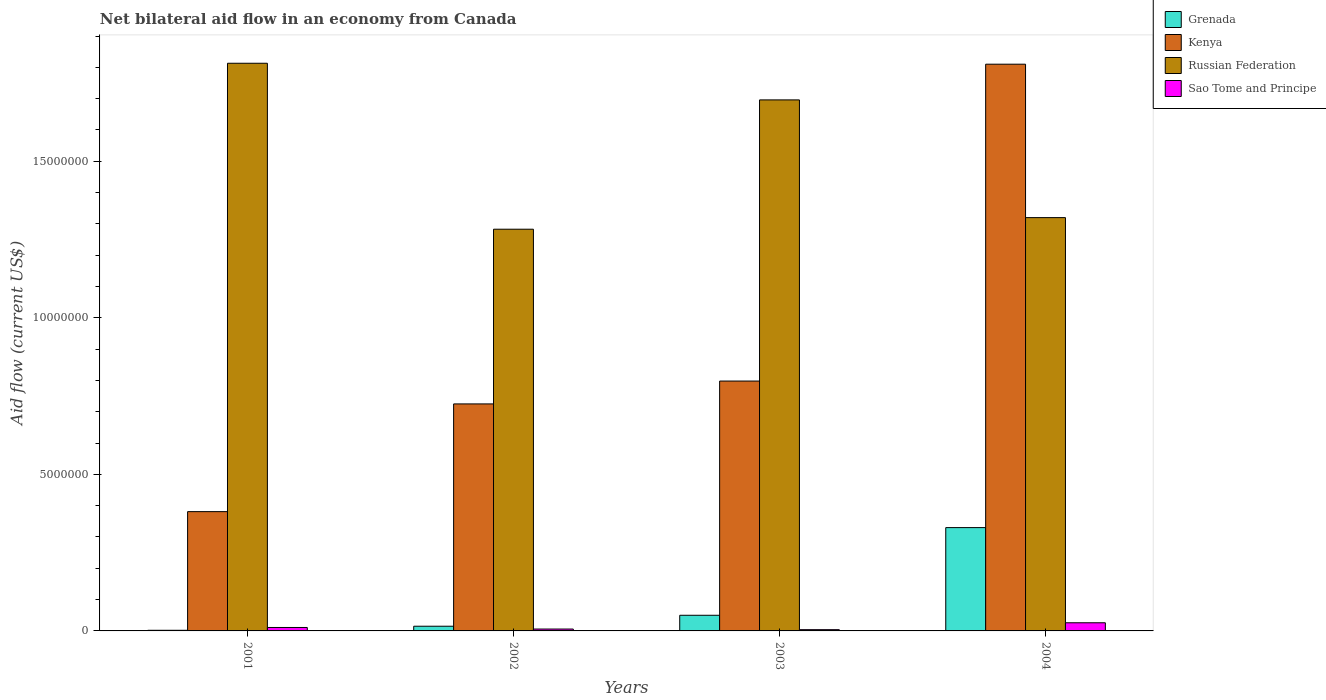Are the number of bars per tick equal to the number of legend labels?
Your answer should be compact. Yes. Are the number of bars on each tick of the X-axis equal?
Your response must be concise. Yes. In how many cases, is the number of bars for a given year not equal to the number of legend labels?
Your response must be concise. 0. What is the net bilateral aid flow in Grenada in 2001?
Your response must be concise. 2.00e+04. Across all years, what is the maximum net bilateral aid flow in Kenya?
Provide a short and direct response. 1.81e+07. Across all years, what is the minimum net bilateral aid flow in Kenya?
Keep it short and to the point. 3.81e+06. In which year was the net bilateral aid flow in Grenada maximum?
Give a very brief answer. 2004. What is the total net bilateral aid flow in Russian Federation in the graph?
Your response must be concise. 6.11e+07. What is the difference between the net bilateral aid flow in Grenada in 2002 and that in 2004?
Provide a short and direct response. -3.15e+06. What is the difference between the net bilateral aid flow in Grenada in 2003 and the net bilateral aid flow in Kenya in 2002?
Keep it short and to the point. -6.75e+06. What is the average net bilateral aid flow in Sao Tome and Principe per year?
Provide a succinct answer. 1.18e+05. In the year 2001, what is the difference between the net bilateral aid flow in Russian Federation and net bilateral aid flow in Grenada?
Provide a succinct answer. 1.81e+07. In how many years, is the net bilateral aid flow in Russian Federation greater than 2000000 US$?
Ensure brevity in your answer.  4. What is the ratio of the net bilateral aid flow in Sao Tome and Principe in 2001 to that in 2004?
Provide a succinct answer. 0.42. Is the net bilateral aid flow in Kenya in 2001 less than that in 2003?
Keep it short and to the point. Yes. Is the difference between the net bilateral aid flow in Russian Federation in 2001 and 2003 greater than the difference between the net bilateral aid flow in Grenada in 2001 and 2003?
Ensure brevity in your answer.  Yes. What is the difference between the highest and the second highest net bilateral aid flow in Sao Tome and Principe?
Your answer should be very brief. 1.50e+05. What is the difference between the highest and the lowest net bilateral aid flow in Russian Federation?
Ensure brevity in your answer.  5.30e+06. In how many years, is the net bilateral aid flow in Grenada greater than the average net bilateral aid flow in Grenada taken over all years?
Make the answer very short. 1. Is it the case that in every year, the sum of the net bilateral aid flow in Sao Tome and Principe and net bilateral aid flow in Kenya is greater than the sum of net bilateral aid flow in Grenada and net bilateral aid flow in Russian Federation?
Offer a very short reply. Yes. What does the 3rd bar from the left in 2004 represents?
Provide a succinct answer. Russian Federation. What does the 3rd bar from the right in 2003 represents?
Ensure brevity in your answer.  Kenya. Are all the bars in the graph horizontal?
Provide a succinct answer. No. What is the difference between two consecutive major ticks on the Y-axis?
Your answer should be very brief. 5.00e+06. Are the values on the major ticks of Y-axis written in scientific E-notation?
Offer a very short reply. No. Does the graph contain grids?
Your response must be concise. No. Where does the legend appear in the graph?
Your answer should be very brief. Top right. What is the title of the graph?
Give a very brief answer. Net bilateral aid flow in an economy from Canada. What is the label or title of the Y-axis?
Give a very brief answer. Aid flow (current US$). What is the Aid flow (current US$) in Kenya in 2001?
Offer a very short reply. 3.81e+06. What is the Aid flow (current US$) of Russian Federation in 2001?
Keep it short and to the point. 1.81e+07. What is the Aid flow (current US$) of Kenya in 2002?
Offer a very short reply. 7.25e+06. What is the Aid flow (current US$) in Russian Federation in 2002?
Your answer should be compact. 1.28e+07. What is the Aid flow (current US$) of Grenada in 2003?
Keep it short and to the point. 5.00e+05. What is the Aid flow (current US$) in Kenya in 2003?
Your answer should be compact. 7.98e+06. What is the Aid flow (current US$) in Russian Federation in 2003?
Your response must be concise. 1.70e+07. What is the Aid flow (current US$) of Grenada in 2004?
Offer a very short reply. 3.30e+06. What is the Aid flow (current US$) in Kenya in 2004?
Give a very brief answer. 1.81e+07. What is the Aid flow (current US$) in Russian Federation in 2004?
Your response must be concise. 1.32e+07. Across all years, what is the maximum Aid flow (current US$) in Grenada?
Your answer should be compact. 3.30e+06. Across all years, what is the maximum Aid flow (current US$) in Kenya?
Your answer should be compact. 1.81e+07. Across all years, what is the maximum Aid flow (current US$) in Russian Federation?
Make the answer very short. 1.81e+07. Across all years, what is the minimum Aid flow (current US$) of Kenya?
Offer a terse response. 3.81e+06. Across all years, what is the minimum Aid flow (current US$) of Russian Federation?
Make the answer very short. 1.28e+07. What is the total Aid flow (current US$) of Grenada in the graph?
Your answer should be compact. 3.97e+06. What is the total Aid flow (current US$) of Kenya in the graph?
Offer a very short reply. 3.71e+07. What is the total Aid flow (current US$) of Russian Federation in the graph?
Make the answer very short. 6.11e+07. What is the total Aid flow (current US$) in Sao Tome and Principe in the graph?
Your answer should be compact. 4.70e+05. What is the difference between the Aid flow (current US$) in Kenya in 2001 and that in 2002?
Provide a short and direct response. -3.44e+06. What is the difference between the Aid flow (current US$) of Russian Federation in 2001 and that in 2002?
Your answer should be compact. 5.30e+06. What is the difference between the Aid flow (current US$) in Sao Tome and Principe in 2001 and that in 2002?
Your answer should be compact. 5.00e+04. What is the difference between the Aid flow (current US$) of Grenada in 2001 and that in 2003?
Give a very brief answer. -4.80e+05. What is the difference between the Aid flow (current US$) of Kenya in 2001 and that in 2003?
Keep it short and to the point. -4.17e+06. What is the difference between the Aid flow (current US$) of Russian Federation in 2001 and that in 2003?
Your response must be concise. 1.17e+06. What is the difference between the Aid flow (current US$) in Sao Tome and Principe in 2001 and that in 2003?
Your response must be concise. 7.00e+04. What is the difference between the Aid flow (current US$) in Grenada in 2001 and that in 2004?
Keep it short and to the point. -3.28e+06. What is the difference between the Aid flow (current US$) of Kenya in 2001 and that in 2004?
Give a very brief answer. -1.43e+07. What is the difference between the Aid flow (current US$) of Russian Federation in 2001 and that in 2004?
Provide a short and direct response. 4.93e+06. What is the difference between the Aid flow (current US$) of Grenada in 2002 and that in 2003?
Your answer should be very brief. -3.50e+05. What is the difference between the Aid flow (current US$) of Kenya in 2002 and that in 2003?
Give a very brief answer. -7.30e+05. What is the difference between the Aid flow (current US$) of Russian Federation in 2002 and that in 2003?
Your answer should be very brief. -4.13e+06. What is the difference between the Aid flow (current US$) in Sao Tome and Principe in 2002 and that in 2003?
Offer a very short reply. 2.00e+04. What is the difference between the Aid flow (current US$) of Grenada in 2002 and that in 2004?
Make the answer very short. -3.15e+06. What is the difference between the Aid flow (current US$) of Kenya in 2002 and that in 2004?
Offer a very short reply. -1.08e+07. What is the difference between the Aid flow (current US$) in Russian Federation in 2002 and that in 2004?
Make the answer very short. -3.70e+05. What is the difference between the Aid flow (current US$) of Grenada in 2003 and that in 2004?
Provide a short and direct response. -2.80e+06. What is the difference between the Aid flow (current US$) of Kenya in 2003 and that in 2004?
Give a very brief answer. -1.01e+07. What is the difference between the Aid flow (current US$) of Russian Federation in 2003 and that in 2004?
Make the answer very short. 3.76e+06. What is the difference between the Aid flow (current US$) of Grenada in 2001 and the Aid flow (current US$) of Kenya in 2002?
Give a very brief answer. -7.23e+06. What is the difference between the Aid flow (current US$) in Grenada in 2001 and the Aid flow (current US$) in Russian Federation in 2002?
Keep it short and to the point. -1.28e+07. What is the difference between the Aid flow (current US$) in Grenada in 2001 and the Aid flow (current US$) in Sao Tome and Principe in 2002?
Give a very brief answer. -4.00e+04. What is the difference between the Aid flow (current US$) in Kenya in 2001 and the Aid flow (current US$) in Russian Federation in 2002?
Provide a short and direct response. -9.02e+06. What is the difference between the Aid flow (current US$) of Kenya in 2001 and the Aid flow (current US$) of Sao Tome and Principe in 2002?
Your answer should be compact. 3.75e+06. What is the difference between the Aid flow (current US$) of Russian Federation in 2001 and the Aid flow (current US$) of Sao Tome and Principe in 2002?
Your answer should be very brief. 1.81e+07. What is the difference between the Aid flow (current US$) in Grenada in 2001 and the Aid flow (current US$) in Kenya in 2003?
Your response must be concise. -7.96e+06. What is the difference between the Aid flow (current US$) of Grenada in 2001 and the Aid flow (current US$) of Russian Federation in 2003?
Your response must be concise. -1.69e+07. What is the difference between the Aid flow (current US$) of Kenya in 2001 and the Aid flow (current US$) of Russian Federation in 2003?
Keep it short and to the point. -1.32e+07. What is the difference between the Aid flow (current US$) of Kenya in 2001 and the Aid flow (current US$) of Sao Tome and Principe in 2003?
Provide a succinct answer. 3.77e+06. What is the difference between the Aid flow (current US$) in Russian Federation in 2001 and the Aid flow (current US$) in Sao Tome and Principe in 2003?
Provide a short and direct response. 1.81e+07. What is the difference between the Aid flow (current US$) of Grenada in 2001 and the Aid flow (current US$) of Kenya in 2004?
Your answer should be compact. -1.81e+07. What is the difference between the Aid flow (current US$) in Grenada in 2001 and the Aid flow (current US$) in Russian Federation in 2004?
Offer a terse response. -1.32e+07. What is the difference between the Aid flow (current US$) of Grenada in 2001 and the Aid flow (current US$) of Sao Tome and Principe in 2004?
Offer a terse response. -2.40e+05. What is the difference between the Aid flow (current US$) in Kenya in 2001 and the Aid flow (current US$) in Russian Federation in 2004?
Offer a terse response. -9.39e+06. What is the difference between the Aid flow (current US$) of Kenya in 2001 and the Aid flow (current US$) of Sao Tome and Principe in 2004?
Make the answer very short. 3.55e+06. What is the difference between the Aid flow (current US$) of Russian Federation in 2001 and the Aid flow (current US$) of Sao Tome and Principe in 2004?
Make the answer very short. 1.79e+07. What is the difference between the Aid flow (current US$) of Grenada in 2002 and the Aid flow (current US$) of Kenya in 2003?
Offer a terse response. -7.83e+06. What is the difference between the Aid flow (current US$) of Grenada in 2002 and the Aid flow (current US$) of Russian Federation in 2003?
Offer a very short reply. -1.68e+07. What is the difference between the Aid flow (current US$) of Kenya in 2002 and the Aid flow (current US$) of Russian Federation in 2003?
Your response must be concise. -9.71e+06. What is the difference between the Aid flow (current US$) of Kenya in 2002 and the Aid flow (current US$) of Sao Tome and Principe in 2003?
Ensure brevity in your answer.  7.21e+06. What is the difference between the Aid flow (current US$) of Russian Federation in 2002 and the Aid flow (current US$) of Sao Tome and Principe in 2003?
Offer a very short reply. 1.28e+07. What is the difference between the Aid flow (current US$) in Grenada in 2002 and the Aid flow (current US$) in Kenya in 2004?
Give a very brief answer. -1.80e+07. What is the difference between the Aid flow (current US$) in Grenada in 2002 and the Aid flow (current US$) in Russian Federation in 2004?
Ensure brevity in your answer.  -1.30e+07. What is the difference between the Aid flow (current US$) in Grenada in 2002 and the Aid flow (current US$) in Sao Tome and Principe in 2004?
Give a very brief answer. -1.10e+05. What is the difference between the Aid flow (current US$) in Kenya in 2002 and the Aid flow (current US$) in Russian Federation in 2004?
Your answer should be compact. -5.95e+06. What is the difference between the Aid flow (current US$) in Kenya in 2002 and the Aid flow (current US$) in Sao Tome and Principe in 2004?
Your answer should be compact. 6.99e+06. What is the difference between the Aid flow (current US$) in Russian Federation in 2002 and the Aid flow (current US$) in Sao Tome and Principe in 2004?
Offer a terse response. 1.26e+07. What is the difference between the Aid flow (current US$) of Grenada in 2003 and the Aid flow (current US$) of Kenya in 2004?
Make the answer very short. -1.76e+07. What is the difference between the Aid flow (current US$) in Grenada in 2003 and the Aid flow (current US$) in Russian Federation in 2004?
Offer a terse response. -1.27e+07. What is the difference between the Aid flow (current US$) of Kenya in 2003 and the Aid flow (current US$) of Russian Federation in 2004?
Offer a terse response. -5.22e+06. What is the difference between the Aid flow (current US$) in Kenya in 2003 and the Aid flow (current US$) in Sao Tome and Principe in 2004?
Offer a very short reply. 7.72e+06. What is the difference between the Aid flow (current US$) of Russian Federation in 2003 and the Aid flow (current US$) of Sao Tome and Principe in 2004?
Your answer should be very brief. 1.67e+07. What is the average Aid flow (current US$) of Grenada per year?
Ensure brevity in your answer.  9.92e+05. What is the average Aid flow (current US$) in Kenya per year?
Make the answer very short. 9.28e+06. What is the average Aid flow (current US$) in Russian Federation per year?
Ensure brevity in your answer.  1.53e+07. What is the average Aid flow (current US$) in Sao Tome and Principe per year?
Keep it short and to the point. 1.18e+05. In the year 2001, what is the difference between the Aid flow (current US$) of Grenada and Aid flow (current US$) of Kenya?
Offer a terse response. -3.79e+06. In the year 2001, what is the difference between the Aid flow (current US$) of Grenada and Aid flow (current US$) of Russian Federation?
Your answer should be compact. -1.81e+07. In the year 2001, what is the difference between the Aid flow (current US$) of Kenya and Aid flow (current US$) of Russian Federation?
Your response must be concise. -1.43e+07. In the year 2001, what is the difference between the Aid flow (current US$) of Kenya and Aid flow (current US$) of Sao Tome and Principe?
Your answer should be very brief. 3.70e+06. In the year 2001, what is the difference between the Aid flow (current US$) of Russian Federation and Aid flow (current US$) of Sao Tome and Principe?
Offer a very short reply. 1.80e+07. In the year 2002, what is the difference between the Aid flow (current US$) in Grenada and Aid flow (current US$) in Kenya?
Your answer should be compact. -7.10e+06. In the year 2002, what is the difference between the Aid flow (current US$) in Grenada and Aid flow (current US$) in Russian Federation?
Make the answer very short. -1.27e+07. In the year 2002, what is the difference between the Aid flow (current US$) in Kenya and Aid flow (current US$) in Russian Federation?
Keep it short and to the point. -5.58e+06. In the year 2002, what is the difference between the Aid flow (current US$) of Kenya and Aid flow (current US$) of Sao Tome and Principe?
Provide a succinct answer. 7.19e+06. In the year 2002, what is the difference between the Aid flow (current US$) of Russian Federation and Aid flow (current US$) of Sao Tome and Principe?
Offer a very short reply. 1.28e+07. In the year 2003, what is the difference between the Aid flow (current US$) of Grenada and Aid flow (current US$) of Kenya?
Offer a terse response. -7.48e+06. In the year 2003, what is the difference between the Aid flow (current US$) of Grenada and Aid flow (current US$) of Russian Federation?
Your response must be concise. -1.65e+07. In the year 2003, what is the difference between the Aid flow (current US$) in Grenada and Aid flow (current US$) in Sao Tome and Principe?
Ensure brevity in your answer.  4.60e+05. In the year 2003, what is the difference between the Aid flow (current US$) of Kenya and Aid flow (current US$) of Russian Federation?
Ensure brevity in your answer.  -8.98e+06. In the year 2003, what is the difference between the Aid flow (current US$) of Kenya and Aid flow (current US$) of Sao Tome and Principe?
Provide a short and direct response. 7.94e+06. In the year 2003, what is the difference between the Aid flow (current US$) in Russian Federation and Aid flow (current US$) in Sao Tome and Principe?
Offer a terse response. 1.69e+07. In the year 2004, what is the difference between the Aid flow (current US$) of Grenada and Aid flow (current US$) of Kenya?
Make the answer very short. -1.48e+07. In the year 2004, what is the difference between the Aid flow (current US$) of Grenada and Aid flow (current US$) of Russian Federation?
Your answer should be very brief. -9.90e+06. In the year 2004, what is the difference between the Aid flow (current US$) of Grenada and Aid flow (current US$) of Sao Tome and Principe?
Ensure brevity in your answer.  3.04e+06. In the year 2004, what is the difference between the Aid flow (current US$) in Kenya and Aid flow (current US$) in Russian Federation?
Provide a short and direct response. 4.90e+06. In the year 2004, what is the difference between the Aid flow (current US$) in Kenya and Aid flow (current US$) in Sao Tome and Principe?
Your answer should be very brief. 1.78e+07. In the year 2004, what is the difference between the Aid flow (current US$) in Russian Federation and Aid flow (current US$) in Sao Tome and Principe?
Your answer should be compact. 1.29e+07. What is the ratio of the Aid flow (current US$) of Grenada in 2001 to that in 2002?
Make the answer very short. 0.13. What is the ratio of the Aid flow (current US$) in Kenya in 2001 to that in 2002?
Provide a short and direct response. 0.53. What is the ratio of the Aid flow (current US$) in Russian Federation in 2001 to that in 2002?
Your answer should be compact. 1.41. What is the ratio of the Aid flow (current US$) of Sao Tome and Principe in 2001 to that in 2002?
Make the answer very short. 1.83. What is the ratio of the Aid flow (current US$) of Kenya in 2001 to that in 2003?
Offer a terse response. 0.48. What is the ratio of the Aid flow (current US$) in Russian Federation in 2001 to that in 2003?
Your response must be concise. 1.07. What is the ratio of the Aid flow (current US$) of Sao Tome and Principe in 2001 to that in 2003?
Provide a short and direct response. 2.75. What is the ratio of the Aid flow (current US$) in Grenada in 2001 to that in 2004?
Keep it short and to the point. 0.01. What is the ratio of the Aid flow (current US$) in Kenya in 2001 to that in 2004?
Your answer should be compact. 0.21. What is the ratio of the Aid flow (current US$) in Russian Federation in 2001 to that in 2004?
Your answer should be compact. 1.37. What is the ratio of the Aid flow (current US$) in Sao Tome and Principe in 2001 to that in 2004?
Provide a succinct answer. 0.42. What is the ratio of the Aid flow (current US$) in Kenya in 2002 to that in 2003?
Your answer should be very brief. 0.91. What is the ratio of the Aid flow (current US$) of Russian Federation in 2002 to that in 2003?
Offer a terse response. 0.76. What is the ratio of the Aid flow (current US$) of Sao Tome and Principe in 2002 to that in 2003?
Your response must be concise. 1.5. What is the ratio of the Aid flow (current US$) of Grenada in 2002 to that in 2004?
Offer a very short reply. 0.05. What is the ratio of the Aid flow (current US$) in Kenya in 2002 to that in 2004?
Make the answer very short. 0.4. What is the ratio of the Aid flow (current US$) in Sao Tome and Principe in 2002 to that in 2004?
Make the answer very short. 0.23. What is the ratio of the Aid flow (current US$) of Grenada in 2003 to that in 2004?
Offer a very short reply. 0.15. What is the ratio of the Aid flow (current US$) in Kenya in 2003 to that in 2004?
Ensure brevity in your answer.  0.44. What is the ratio of the Aid flow (current US$) of Russian Federation in 2003 to that in 2004?
Your answer should be very brief. 1.28. What is the ratio of the Aid flow (current US$) in Sao Tome and Principe in 2003 to that in 2004?
Your answer should be compact. 0.15. What is the difference between the highest and the second highest Aid flow (current US$) of Grenada?
Provide a short and direct response. 2.80e+06. What is the difference between the highest and the second highest Aid flow (current US$) in Kenya?
Your answer should be compact. 1.01e+07. What is the difference between the highest and the second highest Aid flow (current US$) in Russian Federation?
Your response must be concise. 1.17e+06. What is the difference between the highest and the lowest Aid flow (current US$) of Grenada?
Make the answer very short. 3.28e+06. What is the difference between the highest and the lowest Aid flow (current US$) in Kenya?
Ensure brevity in your answer.  1.43e+07. What is the difference between the highest and the lowest Aid flow (current US$) of Russian Federation?
Make the answer very short. 5.30e+06. What is the difference between the highest and the lowest Aid flow (current US$) in Sao Tome and Principe?
Your response must be concise. 2.20e+05. 